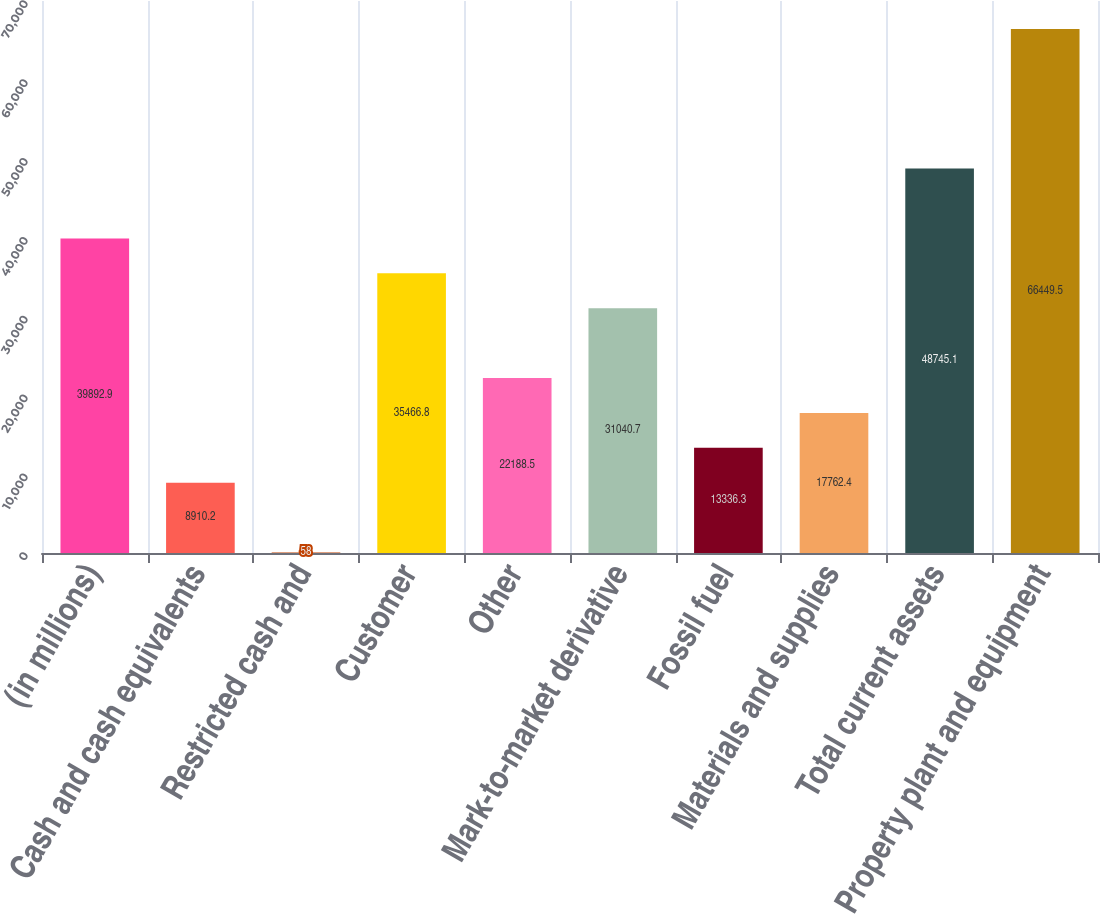<chart> <loc_0><loc_0><loc_500><loc_500><bar_chart><fcel>(in millions)<fcel>Cash and cash equivalents<fcel>Restricted cash and<fcel>Customer<fcel>Other<fcel>Mark-to-market derivative<fcel>Fossil fuel<fcel>Materials and supplies<fcel>Total current assets<fcel>Property plant and equipment<nl><fcel>39892.9<fcel>8910.2<fcel>58<fcel>35466.8<fcel>22188.5<fcel>31040.7<fcel>13336.3<fcel>17762.4<fcel>48745.1<fcel>66449.5<nl></chart> 